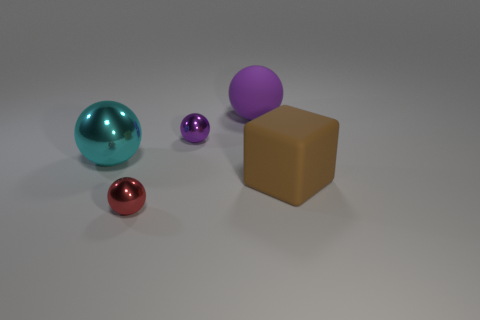What number of spheres are matte things or brown matte objects?
Make the answer very short. 1. Do the large purple rubber thing and the metal thing that is in front of the large brown thing have the same shape?
Your response must be concise. Yes. What number of objects have the same size as the cyan ball?
Provide a succinct answer. 2. Does the matte object behind the large block have the same shape as the small thing behind the brown matte cube?
Give a very brief answer. Yes. What is the shape of the small object that is the same color as the matte ball?
Offer a very short reply. Sphere. There is a tiny sphere that is behind the small ball in front of the big metal object; what color is it?
Ensure brevity in your answer.  Purple. The big shiny object that is the same shape as the purple matte thing is what color?
Offer a very short reply. Cyan. Are there any other things that have the same material as the cube?
Offer a terse response. Yes. What size is the rubber thing that is the same shape as the purple metal object?
Offer a very short reply. Large. What material is the purple thing right of the small purple thing?
Offer a very short reply. Rubber. 